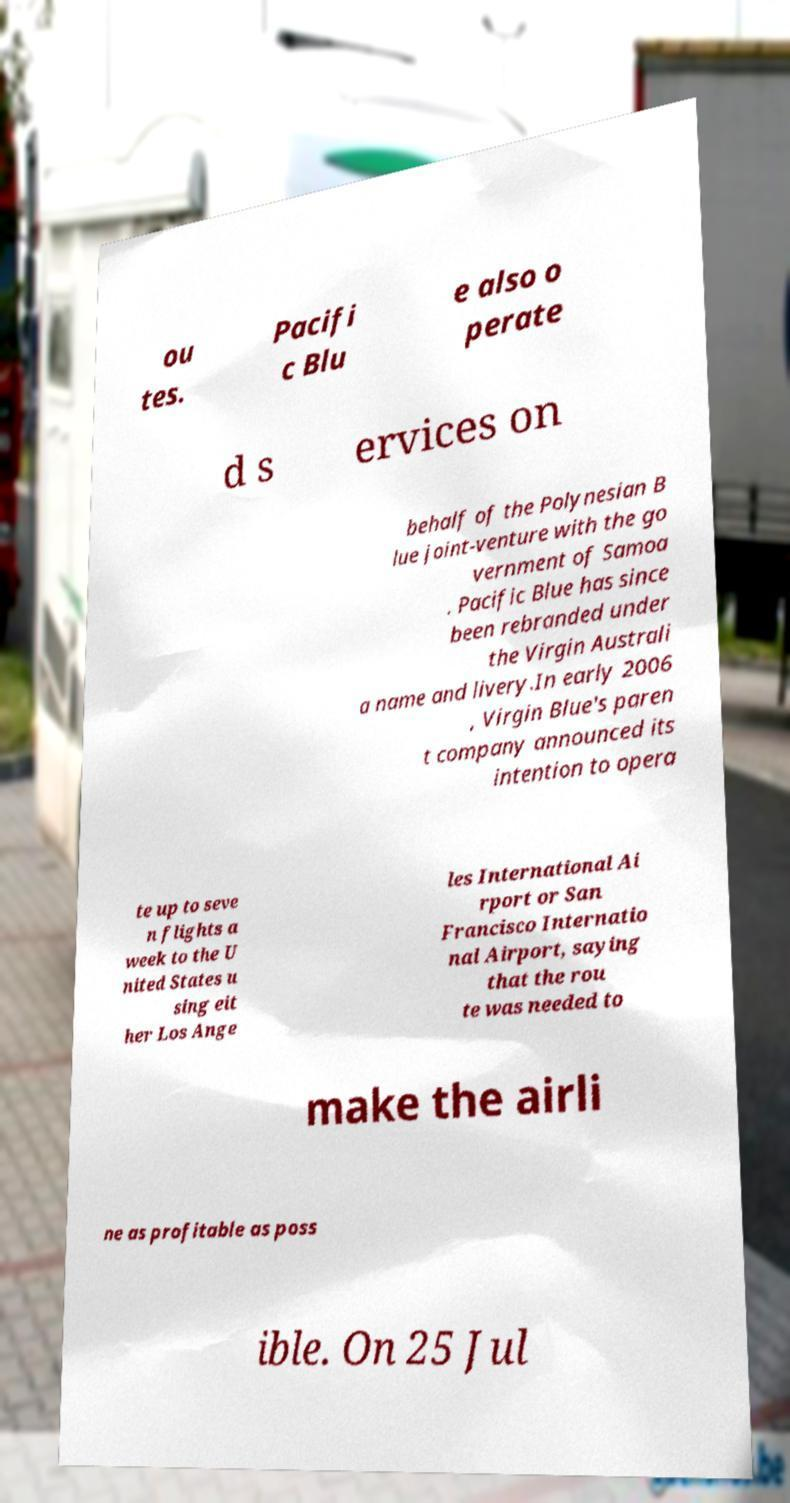Can you accurately transcribe the text from the provided image for me? ou tes. Pacifi c Blu e also o perate d s ervices on behalf of the Polynesian B lue joint-venture with the go vernment of Samoa . Pacific Blue has since been rebranded under the Virgin Australi a name and livery.In early 2006 , Virgin Blue's paren t company announced its intention to opera te up to seve n flights a week to the U nited States u sing eit her Los Ange les International Ai rport or San Francisco Internatio nal Airport, saying that the rou te was needed to make the airli ne as profitable as poss ible. On 25 Jul 